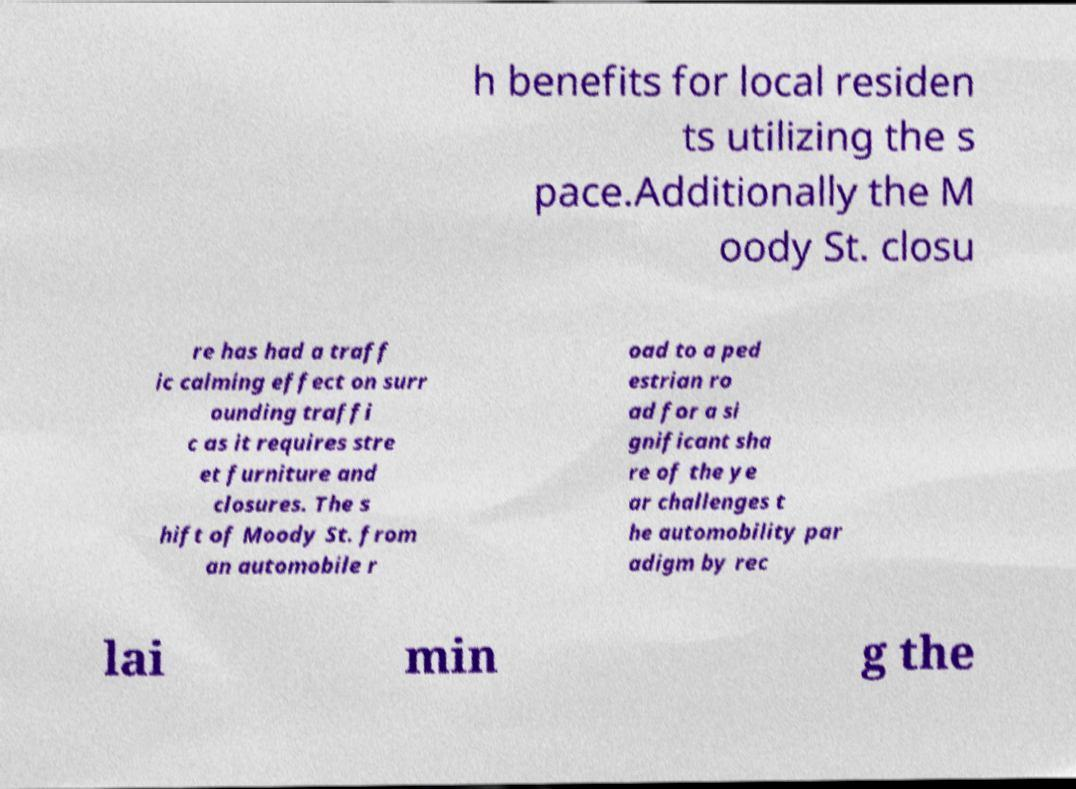Can you read and provide the text displayed in the image?This photo seems to have some interesting text. Can you extract and type it out for me? h benefits for local residen ts utilizing the s pace.Additionally the M oody St. closu re has had a traff ic calming effect on surr ounding traffi c as it requires stre et furniture and closures. The s hift of Moody St. from an automobile r oad to a ped estrian ro ad for a si gnificant sha re of the ye ar challenges t he automobility par adigm by rec lai min g the 